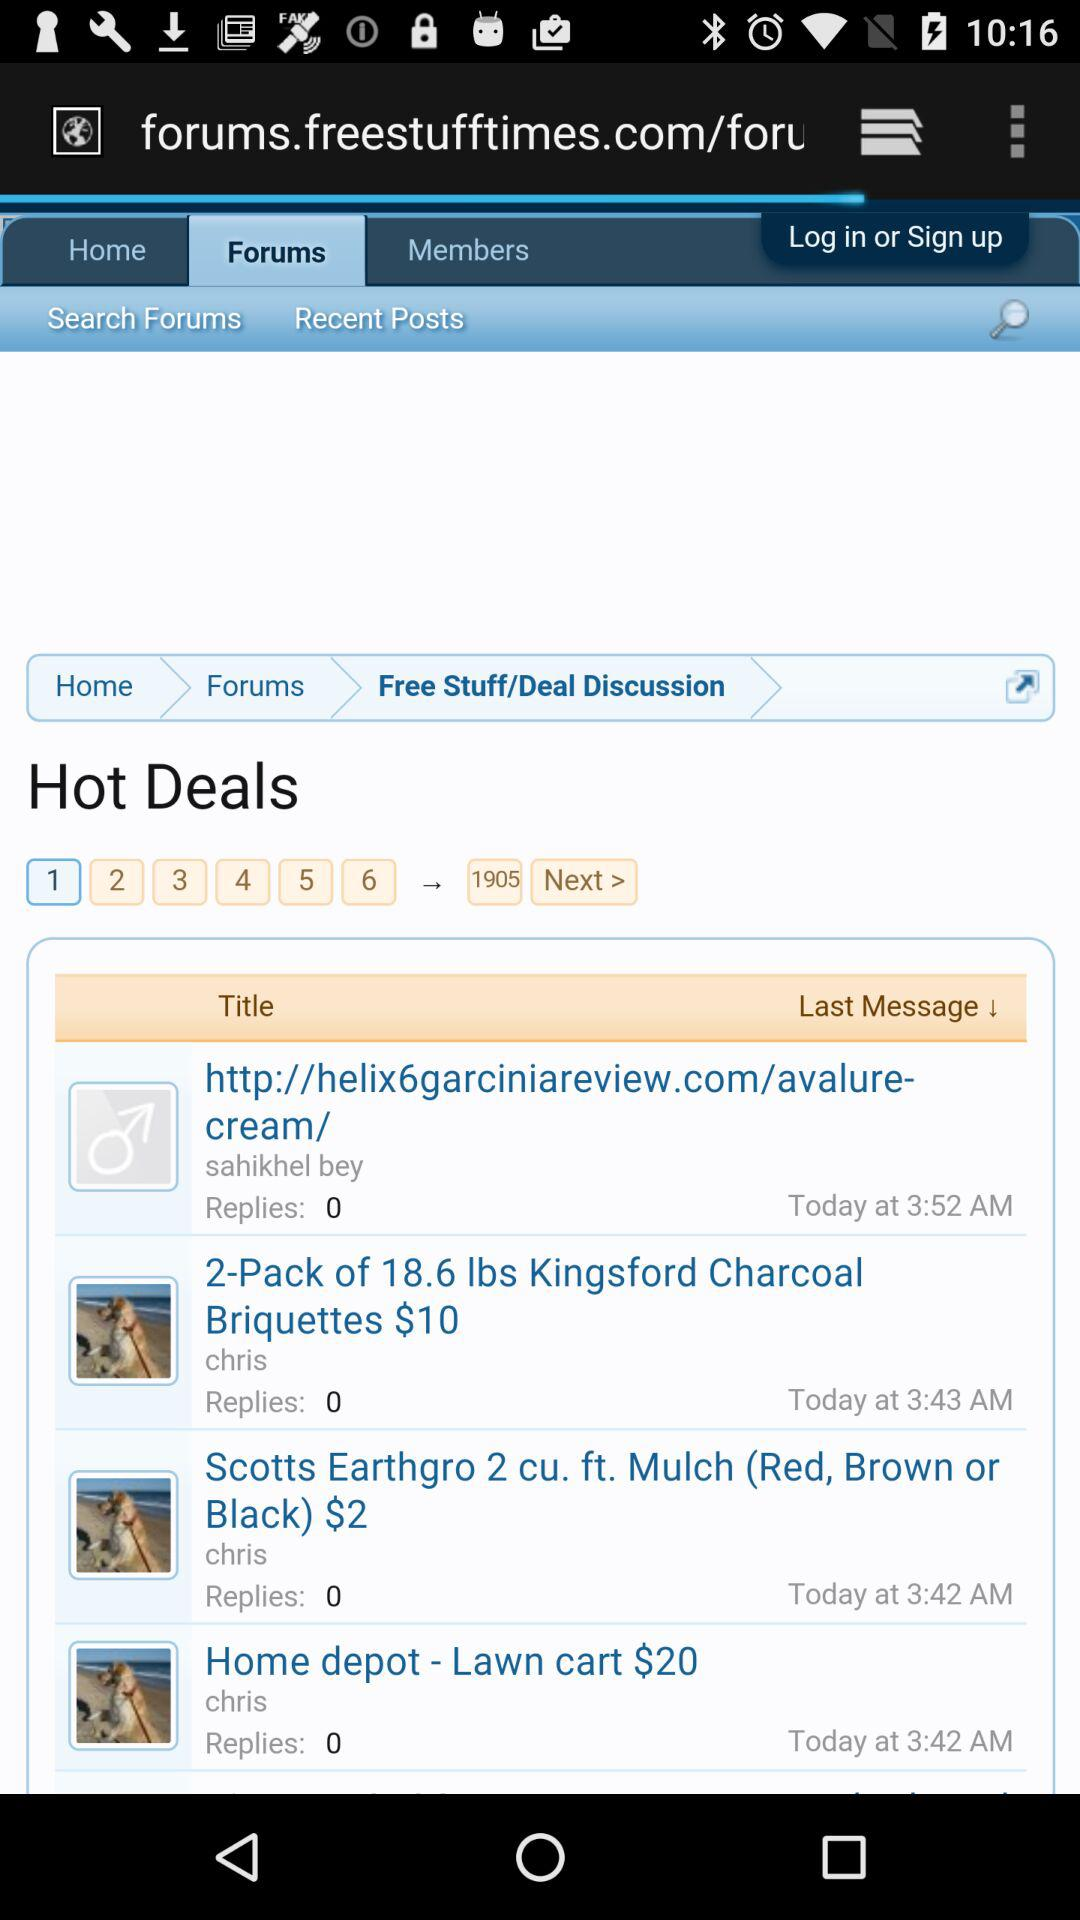What is the title of the deal posted at 3:52 a.m.? The title of the deal is "http://helix6garciniareview.com/avalure- Last Message! cream/". 